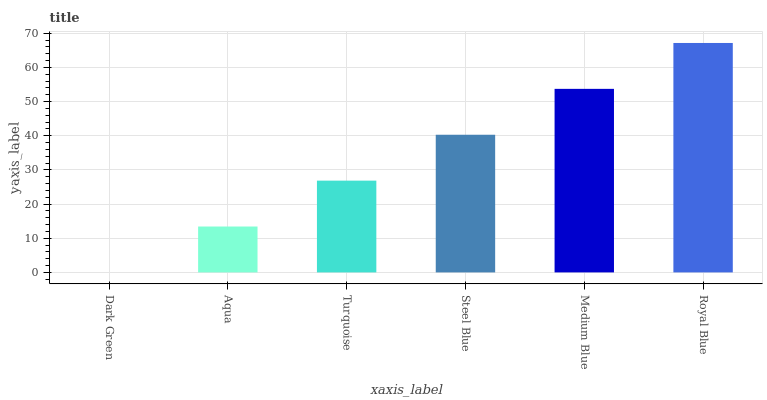Is Dark Green the minimum?
Answer yes or no. Yes. Is Royal Blue the maximum?
Answer yes or no. Yes. Is Aqua the minimum?
Answer yes or no. No. Is Aqua the maximum?
Answer yes or no. No. Is Aqua greater than Dark Green?
Answer yes or no. Yes. Is Dark Green less than Aqua?
Answer yes or no. Yes. Is Dark Green greater than Aqua?
Answer yes or no. No. Is Aqua less than Dark Green?
Answer yes or no. No. Is Steel Blue the high median?
Answer yes or no. Yes. Is Turquoise the low median?
Answer yes or no. Yes. Is Royal Blue the high median?
Answer yes or no. No. Is Aqua the low median?
Answer yes or no. No. 